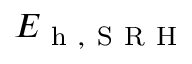<formula> <loc_0><loc_0><loc_500><loc_500>E _ { h , S R H }</formula> 